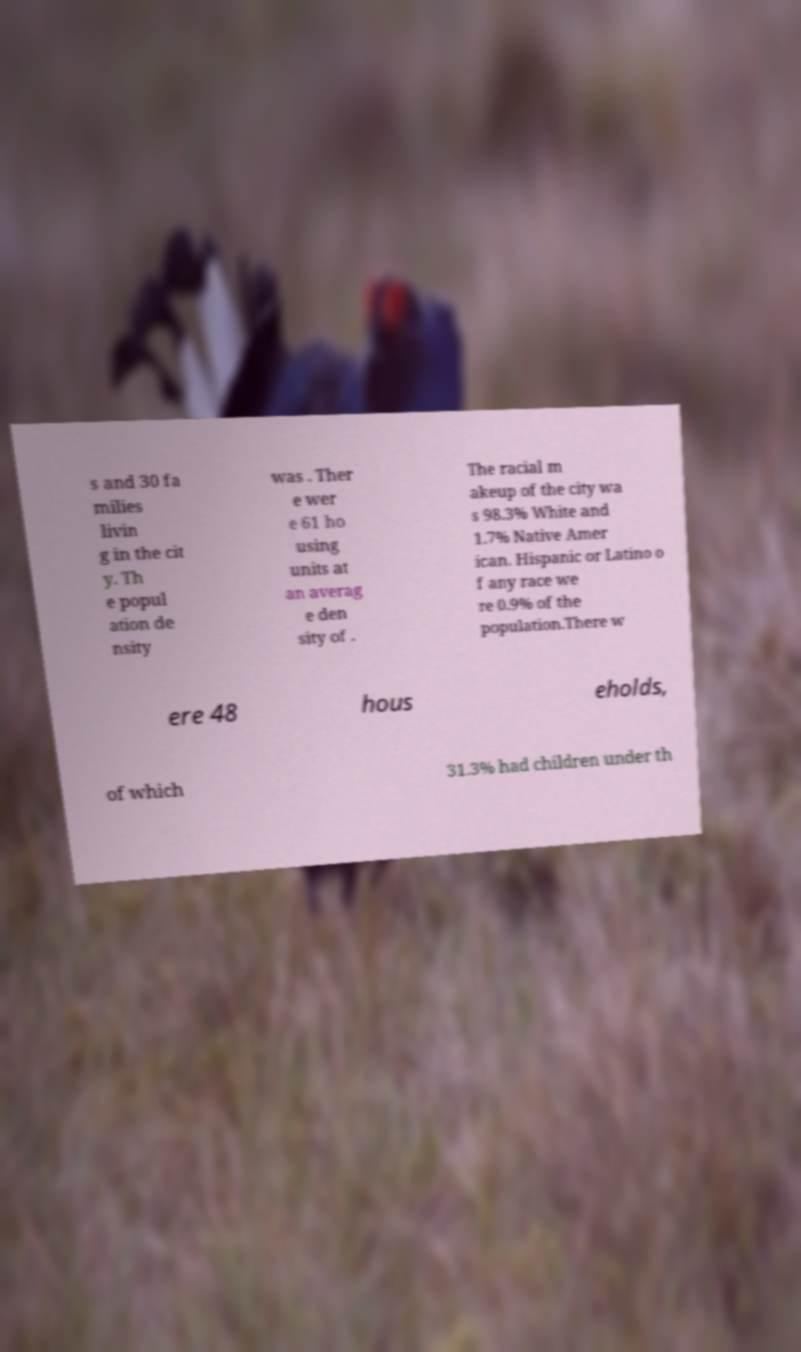Please identify and transcribe the text found in this image. s and 30 fa milies livin g in the cit y. Th e popul ation de nsity was . Ther e wer e 61 ho using units at an averag e den sity of . The racial m akeup of the city wa s 98.3% White and 1.7% Native Amer ican. Hispanic or Latino o f any race we re 0.9% of the population.There w ere 48 hous eholds, of which 31.3% had children under th 